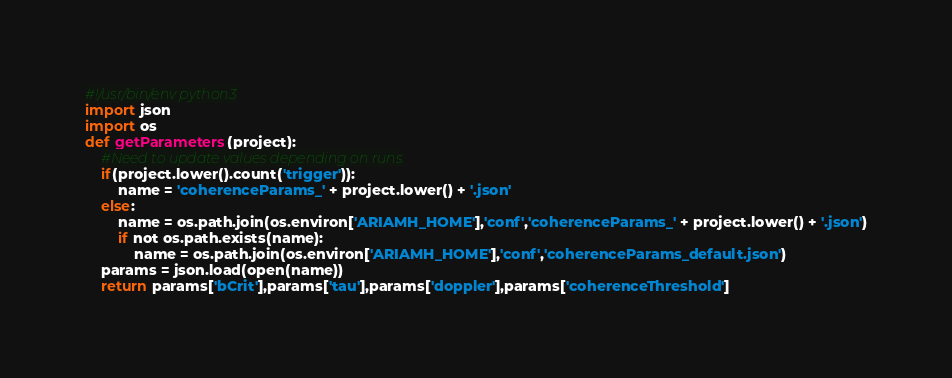Convert code to text. <code><loc_0><loc_0><loc_500><loc_500><_Python_>#!/usr/bin/env python3
import json
import os
def getParameters(project):
    #Need to update values depending on runs
    if(project.lower().count('trigger')):
        name = 'coherenceParams_' + project.lower() + '.json'
    else:
        name = os.path.join(os.environ['ARIAMH_HOME'],'conf','coherenceParams_' + project.lower() + '.json')
        if not os.path.exists(name):
            name = os.path.join(os.environ['ARIAMH_HOME'],'conf','coherenceParams_default.json')
    params = json.load(open(name))
    return params['bCrit'],params['tau'],params['doppler'],params['coherenceThreshold']
</code> 